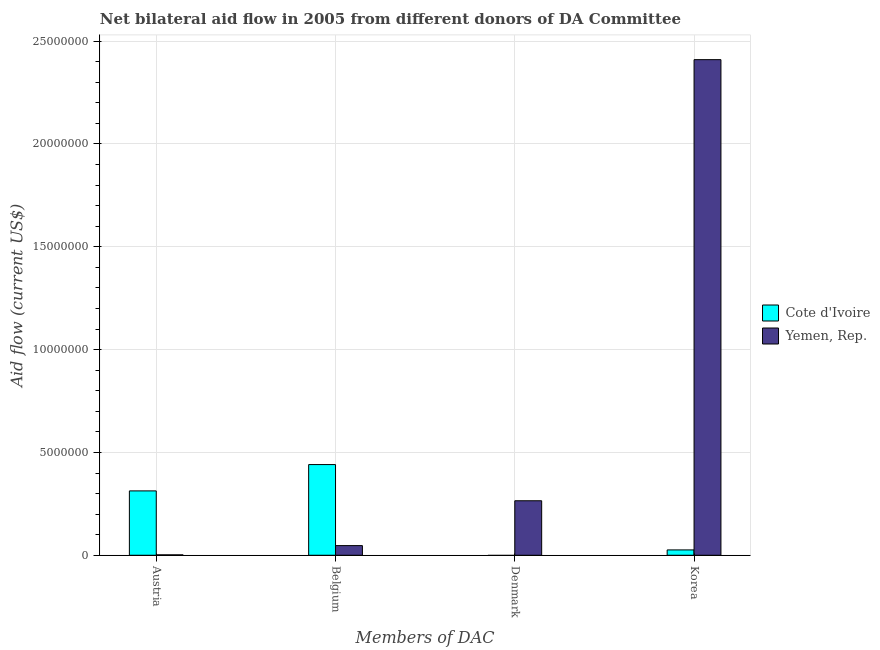How many different coloured bars are there?
Your response must be concise. 2. How many bars are there on the 4th tick from the left?
Make the answer very short. 2. What is the amount of aid given by belgium in Cote d'Ivoire?
Give a very brief answer. 4.41e+06. Across all countries, what is the maximum amount of aid given by korea?
Give a very brief answer. 2.41e+07. Across all countries, what is the minimum amount of aid given by denmark?
Your answer should be compact. 0. In which country was the amount of aid given by austria maximum?
Your response must be concise. Cote d'Ivoire. What is the total amount of aid given by belgium in the graph?
Your response must be concise. 4.88e+06. What is the difference between the amount of aid given by belgium in Yemen, Rep. and that in Cote d'Ivoire?
Your response must be concise. -3.94e+06. What is the difference between the amount of aid given by denmark in Yemen, Rep. and the amount of aid given by korea in Cote d'Ivoire?
Give a very brief answer. 2.39e+06. What is the average amount of aid given by denmark per country?
Give a very brief answer. 1.32e+06. What is the difference between the amount of aid given by belgium and amount of aid given by denmark in Yemen, Rep.?
Offer a terse response. -2.18e+06. In how many countries, is the amount of aid given by denmark greater than 23000000 US$?
Your answer should be very brief. 0. What is the ratio of the amount of aid given by belgium in Cote d'Ivoire to that in Yemen, Rep.?
Your response must be concise. 9.38. Is the amount of aid given by austria in Cote d'Ivoire less than that in Yemen, Rep.?
Provide a short and direct response. No. Is the difference between the amount of aid given by belgium in Yemen, Rep. and Cote d'Ivoire greater than the difference between the amount of aid given by korea in Yemen, Rep. and Cote d'Ivoire?
Offer a very short reply. No. What is the difference between the highest and the second highest amount of aid given by korea?
Offer a terse response. 2.38e+07. What is the difference between the highest and the lowest amount of aid given by korea?
Provide a succinct answer. 2.38e+07. In how many countries, is the amount of aid given by denmark greater than the average amount of aid given by denmark taken over all countries?
Provide a succinct answer. 1. Is the sum of the amount of aid given by korea in Cote d'Ivoire and Yemen, Rep. greater than the maximum amount of aid given by belgium across all countries?
Your answer should be very brief. Yes. Is it the case that in every country, the sum of the amount of aid given by belgium and amount of aid given by austria is greater than the sum of amount of aid given by korea and amount of aid given by denmark?
Your answer should be very brief. No. Is it the case that in every country, the sum of the amount of aid given by austria and amount of aid given by belgium is greater than the amount of aid given by denmark?
Keep it short and to the point. No. How many bars are there?
Your response must be concise. 7. What is the difference between two consecutive major ticks on the Y-axis?
Your response must be concise. 5.00e+06. Does the graph contain any zero values?
Make the answer very short. Yes. Does the graph contain grids?
Provide a succinct answer. Yes. What is the title of the graph?
Your answer should be compact. Net bilateral aid flow in 2005 from different donors of DA Committee. Does "Zambia" appear as one of the legend labels in the graph?
Make the answer very short. No. What is the label or title of the X-axis?
Your answer should be very brief. Members of DAC. What is the Aid flow (current US$) in Cote d'Ivoire in Austria?
Offer a very short reply. 3.13e+06. What is the Aid flow (current US$) of Cote d'Ivoire in Belgium?
Your answer should be compact. 4.41e+06. What is the Aid flow (current US$) in Yemen, Rep. in Belgium?
Provide a succinct answer. 4.70e+05. What is the Aid flow (current US$) of Yemen, Rep. in Denmark?
Keep it short and to the point. 2.65e+06. What is the Aid flow (current US$) in Yemen, Rep. in Korea?
Your answer should be very brief. 2.41e+07. Across all Members of DAC, what is the maximum Aid flow (current US$) in Cote d'Ivoire?
Provide a short and direct response. 4.41e+06. Across all Members of DAC, what is the maximum Aid flow (current US$) in Yemen, Rep.?
Keep it short and to the point. 2.41e+07. Across all Members of DAC, what is the minimum Aid flow (current US$) in Cote d'Ivoire?
Give a very brief answer. 0. Across all Members of DAC, what is the minimum Aid flow (current US$) in Yemen, Rep.?
Your response must be concise. 2.00e+04. What is the total Aid flow (current US$) in Cote d'Ivoire in the graph?
Give a very brief answer. 7.80e+06. What is the total Aid flow (current US$) in Yemen, Rep. in the graph?
Offer a terse response. 2.72e+07. What is the difference between the Aid flow (current US$) of Cote d'Ivoire in Austria and that in Belgium?
Make the answer very short. -1.28e+06. What is the difference between the Aid flow (current US$) in Yemen, Rep. in Austria and that in Belgium?
Your response must be concise. -4.50e+05. What is the difference between the Aid flow (current US$) in Yemen, Rep. in Austria and that in Denmark?
Your answer should be compact. -2.63e+06. What is the difference between the Aid flow (current US$) in Cote d'Ivoire in Austria and that in Korea?
Your response must be concise. 2.87e+06. What is the difference between the Aid flow (current US$) of Yemen, Rep. in Austria and that in Korea?
Keep it short and to the point. -2.41e+07. What is the difference between the Aid flow (current US$) of Yemen, Rep. in Belgium and that in Denmark?
Give a very brief answer. -2.18e+06. What is the difference between the Aid flow (current US$) of Cote d'Ivoire in Belgium and that in Korea?
Offer a very short reply. 4.15e+06. What is the difference between the Aid flow (current US$) in Yemen, Rep. in Belgium and that in Korea?
Make the answer very short. -2.36e+07. What is the difference between the Aid flow (current US$) in Yemen, Rep. in Denmark and that in Korea?
Your response must be concise. -2.14e+07. What is the difference between the Aid flow (current US$) in Cote d'Ivoire in Austria and the Aid flow (current US$) in Yemen, Rep. in Belgium?
Offer a very short reply. 2.66e+06. What is the difference between the Aid flow (current US$) in Cote d'Ivoire in Austria and the Aid flow (current US$) in Yemen, Rep. in Korea?
Offer a very short reply. -2.10e+07. What is the difference between the Aid flow (current US$) in Cote d'Ivoire in Belgium and the Aid flow (current US$) in Yemen, Rep. in Denmark?
Your answer should be compact. 1.76e+06. What is the difference between the Aid flow (current US$) in Cote d'Ivoire in Belgium and the Aid flow (current US$) in Yemen, Rep. in Korea?
Your answer should be very brief. -1.97e+07. What is the average Aid flow (current US$) in Cote d'Ivoire per Members of DAC?
Keep it short and to the point. 1.95e+06. What is the average Aid flow (current US$) of Yemen, Rep. per Members of DAC?
Your answer should be compact. 6.81e+06. What is the difference between the Aid flow (current US$) in Cote d'Ivoire and Aid flow (current US$) in Yemen, Rep. in Austria?
Give a very brief answer. 3.11e+06. What is the difference between the Aid flow (current US$) of Cote d'Ivoire and Aid flow (current US$) of Yemen, Rep. in Belgium?
Offer a terse response. 3.94e+06. What is the difference between the Aid flow (current US$) of Cote d'Ivoire and Aid flow (current US$) of Yemen, Rep. in Korea?
Your response must be concise. -2.38e+07. What is the ratio of the Aid flow (current US$) in Cote d'Ivoire in Austria to that in Belgium?
Offer a terse response. 0.71. What is the ratio of the Aid flow (current US$) of Yemen, Rep. in Austria to that in Belgium?
Keep it short and to the point. 0.04. What is the ratio of the Aid flow (current US$) in Yemen, Rep. in Austria to that in Denmark?
Provide a succinct answer. 0.01. What is the ratio of the Aid flow (current US$) of Cote d'Ivoire in Austria to that in Korea?
Your answer should be very brief. 12.04. What is the ratio of the Aid flow (current US$) in Yemen, Rep. in Austria to that in Korea?
Make the answer very short. 0. What is the ratio of the Aid flow (current US$) of Yemen, Rep. in Belgium to that in Denmark?
Your answer should be very brief. 0.18. What is the ratio of the Aid flow (current US$) of Cote d'Ivoire in Belgium to that in Korea?
Give a very brief answer. 16.96. What is the ratio of the Aid flow (current US$) of Yemen, Rep. in Belgium to that in Korea?
Your answer should be very brief. 0.02. What is the ratio of the Aid flow (current US$) in Yemen, Rep. in Denmark to that in Korea?
Provide a short and direct response. 0.11. What is the difference between the highest and the second highest Aid flow (current US$) of Cote d'Ivoire?
Keep it short and to the point. 1.28e+06. What is the difference between the highest and the second highest Aid flow (current US$) of Yemen, Rep.?
Offer a very short reply. 2.14e+07. What is the difference between the highest and the lowest Aid flow (current US$) in Cote d'Ivoire?
Your answer should be compact. 4.41e+06. What is the difference between the highest and the lowest Aid flow (current US$) in Yemen, Rep.?
Provide a succinct answer. 2.41e+07. 